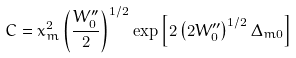<formula> <loc_0><loc_0><loc_500><loc_500>C = x _ { m } ^ { 2 } \left ( \frac { W _ { 0 } ^ { \prime \prime } } { 2 } \right ) ^ { 1 / 2 } \exp \left [ 2 \left ( 2 W _ { 0 } ^ { \prime \prime } \right ) ^ { 1 / 2 } \Delta _ { m 0 } \right ]</formula> 